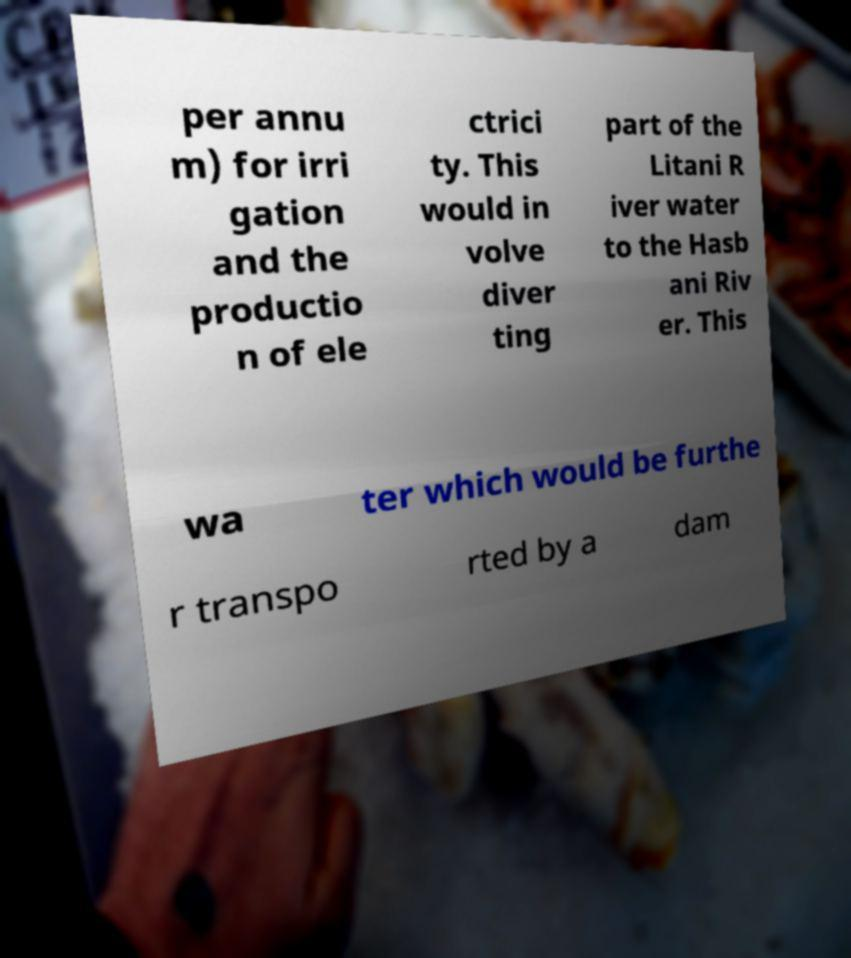Please identify and transcribe the text found in this image. per annu m) for irri gation and the productio n of ele ctrici ty. This would in volve diver ting part of the Litani R iver water to the Hasb ani Riv er. This wa ter which would be furthe r transpo rted by a dam 